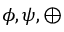<formula> <loc_0><loc_0><loc_500><loc_500>\phi , \psi , \oplus</formula> 